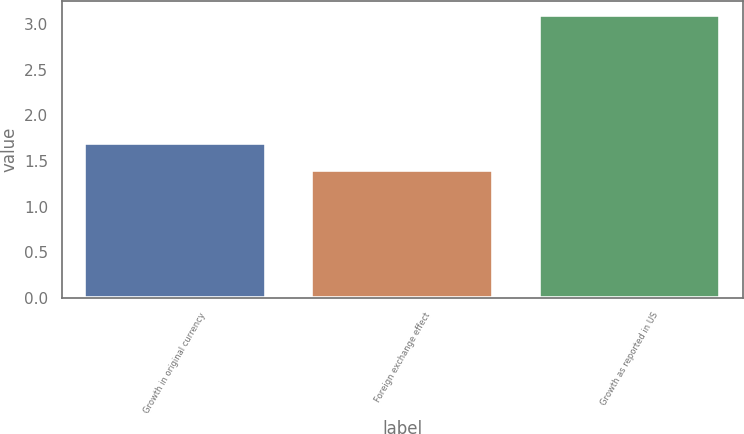<chart> <loc_0><loc_0><loc_500><loc_500><bar_chart><fcel>Growth in original currency<fcel>Foreign exchange effect<fcel>Growth as reported in US<nl><fcel>1.7<fcel>1.4<fcel>3.1<nl></chart> 